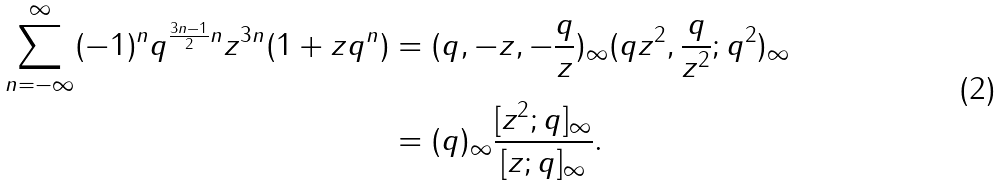<formula> <loc_0><loc_0><loc_500><loc_500>\sum _ { n = - \infty } ^ { \infty } ( - 1 ) ^ { n } q ^ { \frac { 3 n - 1 } { 2 } n } z ^ { 3 n } ( 1 + z q ^ { n } ) & = ( q , - z , - \frac { q } { z } ) _ { \infty } ( q z ^ { 2 } , \frac { q } { z ^ { 2 } } ; q ^ { 2 } ) _ { \infty } \\ & = ( q ) _ { \infty } \frac { [ z ^ { 2 } ; q ] _ { \infty } } { [ z ; q ] _ { \infty } } .</formula> 